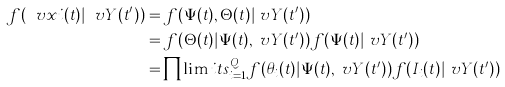Convert formula to latex. <formula><loc_0><loc_0><loc_500><loc_500>f ( \ v x i ( t ) | \ v Y ( t ^ { \prime } ) ) & = f ( \Psi ( t ) , \Theta ( t ) | \ v Y ( t ^ { \prime } ) ) \\ & = f ( \Theta ( t ) | \Psi ( t ) , \ v Y ( t ^ { \prime } ) ) f ( \Psi ( t ) | \ v Y ( t ^ { \prime } ) ) \\ & = \prod \lim i t s _ { i = 1 } ^ { Q } f ( \theta _ { i } ( t ) | \Psi ( t ) , \ v Y ( t ^ { \prime } ) ) f ( I _ { i } ( t ) | \ v Y ( t ^ { \prime } ) )</formula> 